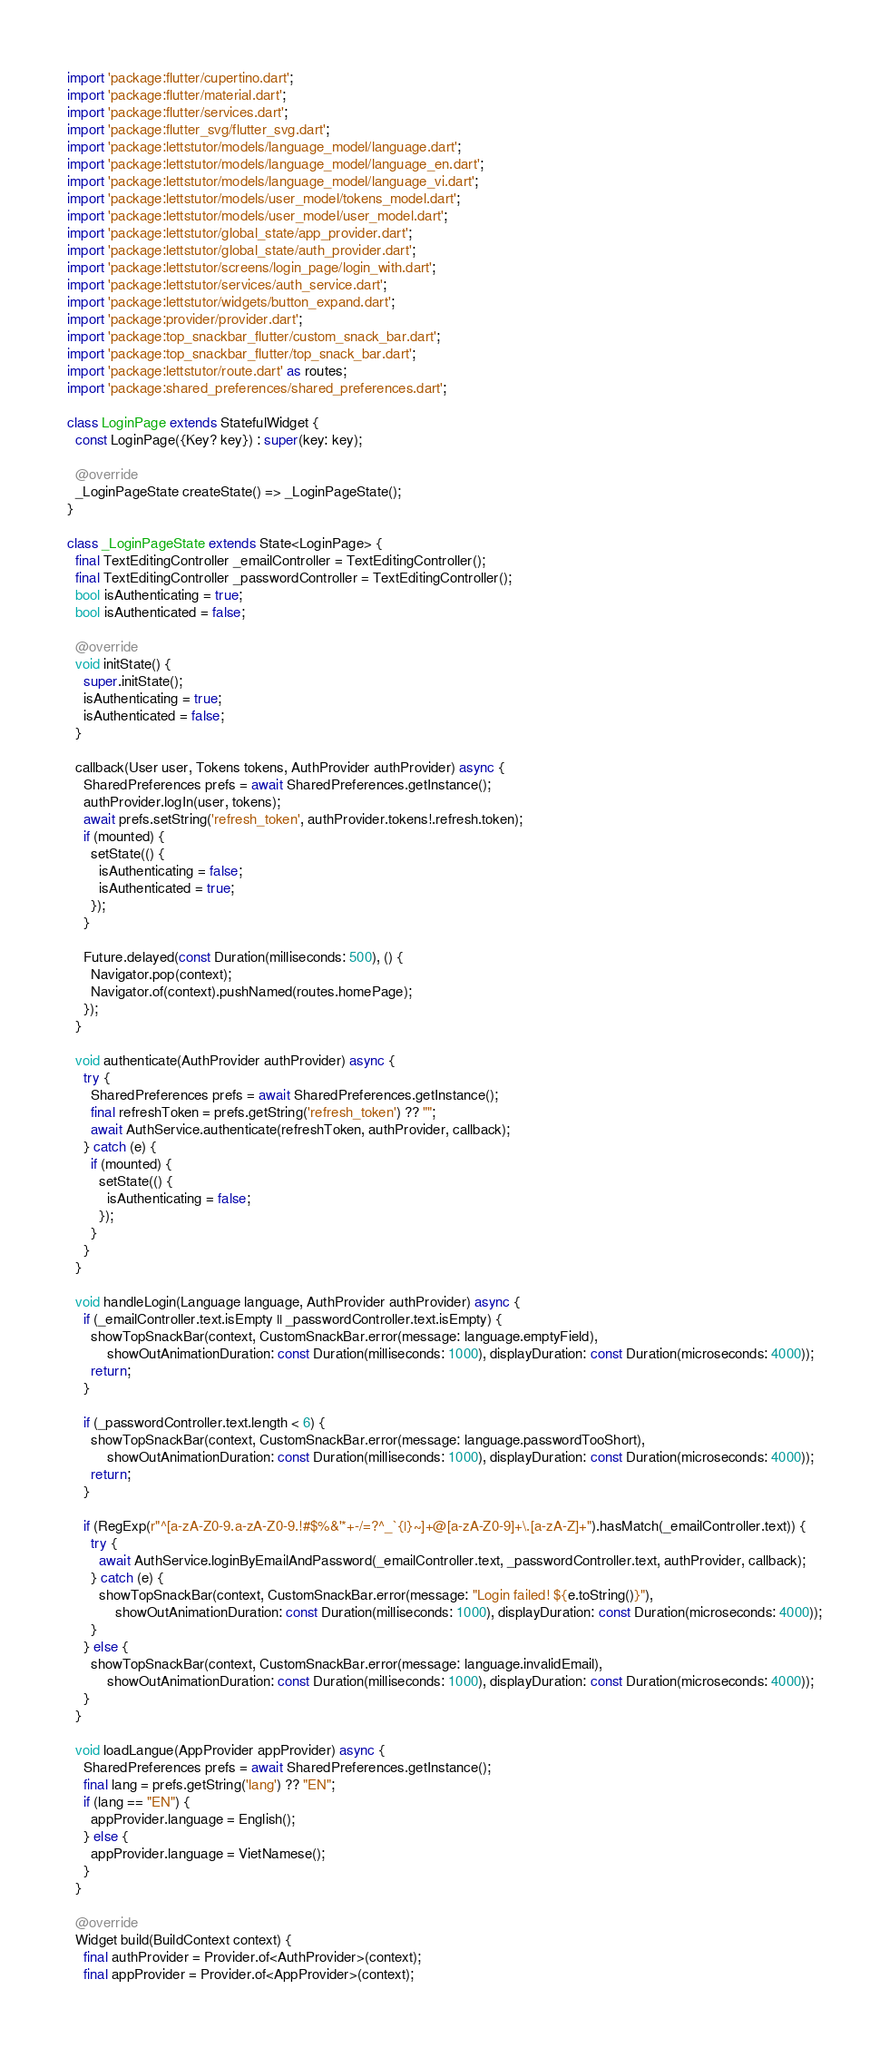Convert code to text. <code><loc_0><loc_0><loc_500><loc_500><_Dart_>import 'package:flutter/cupertino.dart';
import 'package:flutter/material.dart';
import 'package:flutter/services.dart';
import 'package:flutter_svg/flutter_svg.dart';
import 'package:lettstutor/models/language_model/language.dart';
import 'package:lettstutor/models/language_model/language_en.dart';
import 'package:lettstutor/models/language_model/language_vi.dart';
import 'package:lettstutor/models/user_model/tokens_model.dart';
import 'package:lettstutor/models/user_model/user_model.dart';
import 'package:lettstutor/global_state/app_provider.dart';
import 'package:lettstutor/global_state/auth_provider.dart';
import 'package:lettstutor/screens/login_page/login_with.dart';
import 'package:lettstutor/services/auth_service.dart';
import 'package:lettstutor/widgets/button_expand.dart';
import 'package:provider/provider.dart';
import 'package:top_snackbar_flutter/custom_snack_bar.dart';
import 'package:top_snackbar_flutter/top_snack_bar.dart';
import 'package:lettstutor/route.dart' as routes;
import 'package:shared_preferences/shared_preferences.dart';

class LoginPage extends StatefulWidget {
  const LoginPage({Key? key}) : super(key: key);

  @override
  _LoginPageState createState() => _LoginPageState();
}

class _LoginPageState extends State<LoginPage> {
  final TextEditingController _emailController = TextEditingController();
  final TextEditingController _passwordController = TextEditingController();
  bool isAuthenticating = true;
  bool isAuthenticated = false;

  @override
  void initState() {
    super.initState();
    isAuthenticating = true;
    isAuthenticated = false;
  }

  callback(User user, Tokens tokens, AuthProvider authProvider) async {
    SharedPreferences prefs = await SharedPreferences.getInstance();
    authProvider.logIn(user, tokens);
    await prefs.setString('refresh_token', authProvider.tokens!.refresh.token);
    if (mounted) {
      setState(() {
        isAuthenticating = false;
        isAuthenticated = true;
      });
    }

    Future.delayed(const Duration(milliseconds: 500), () {
      Navigator.pop(context);
      Navigator.of(context).pushNamed(routes.homePage);
    });
  }

  void authenticate(AuthProvider authProvider) async {
    try {
      SharedPreferences prefs = await SharedPreferences.getInstance();
      final refreshToken = prefs.getString('refresh_token') ?? "";
      await AuthService.authenticate(refreshToken, authProvider, callback);
    } catch (e) {
      if (mounted) {
        setState(() {
          isAuthenticating = false;
        });
      }
    }
  }

  void handleLogin(Language language, AuthProvider authProvider) async {
    if (_emailController.text.isEmpty || _passwordController.text.isEmpty) {
      showTopSnackBar(context, CustomSnackBar.error(message: language.emptyField),
          showOutAnimationDuration: const Duration(milliseconds: 1000), displayDuration: const Duration(microseconds: 4000));
      return;
    }

    if (_passwordController.text.length < 6) {
      showTopSnackBar(context, CustomSnackBar.error(message: language.passwordTooShort),
          showOutAnimationDuration: const Duration(milliseconds: 1000), displayDuration: const Duration(microseconds: 4000));
      return;
    }

    if (RegExp(r"^[a-zA-Z0-9.a-zA-Z0-9.!#$%&'*+-/=?^_`{|}~]+@[a-zA-Z0-9]+\.[a-zA-Z]+").hasMatch(_emailController.text)) {
      try {
        await AuthService.loginByEmailAndPassword(_emailController.text, _passwordController.text, authProvider, callback);
      } catch (e) {
        showTopSnackBar(context, CustomSnackBar.error(message: "Login failed! ${e.toString()}"),
            showOutAnimationDuration: const Duration(milliseconds: 1000), displayDuration: const Duration(microseconds: 4000));
      }
    } else {
      showTopSnackBar(context, CustomSnackBar.error(message: language.invalidEmail),
          showOutAnimationDuration: const Duration(milliseconds: 1000), displayDuration: const Duration(microseconds: 4000));
    }
  }

  void loadLangue(AppProvider appProvider) async {
    SharedPreferences prefs = await SharedPreferences.getInstance();
    final lang = prefs.getString('lang') ?? "EN";
    if (lang == "EN") {
      appProvider.language = English();
    } else {
      appProvider.language = VietNamese();
    }
  }

  @override
  Widget build(BuildContext context) {
    final authProvider = Provider.of<AuthProvider>(context);
    final appProvider = Provider.of<AppProvider>(context);</code> 